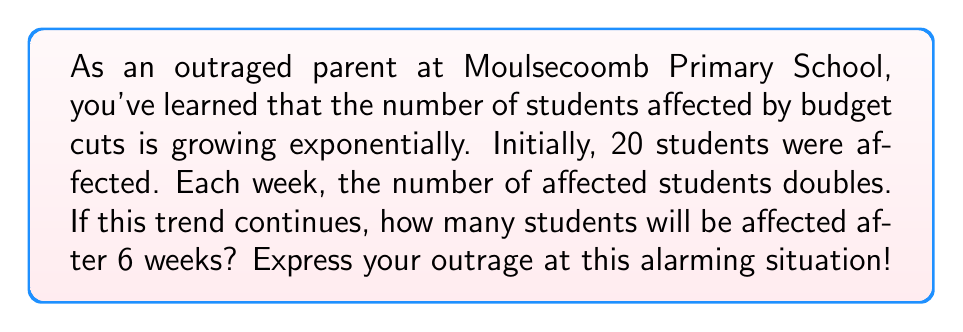What is the answer to this math problem? Let's approach this problem step-by-step using the exponential growth formula:

$$A = A_0 \cdot r^t$$

Where:
$A$ = final amount
$A_0$ = initial amount
$r$ = growth rate
$t$ = time period

Given:
$A_0 = 20$ (initial number of affected students)
$r = 2$ (the number doubles each week)
$t = 6$ weeks

Let's plug these values into our formula:

$$A = 20 \cdot 2^6$$

Now, let's calculate:

$$\begin{align}
A &= 20 \cdot 2^6 \\
&= 20 \cdot 64 \\
&= 1,280
\end{align}$$

This result is truly alarming! In just 6 weeks, the number of affected students has grown from 20 to 1,280. This exponential increase demonstrates the devastating impact of these budget cuts on our school community.
Answer: 1,280 students will be affected after 6 weeks. 